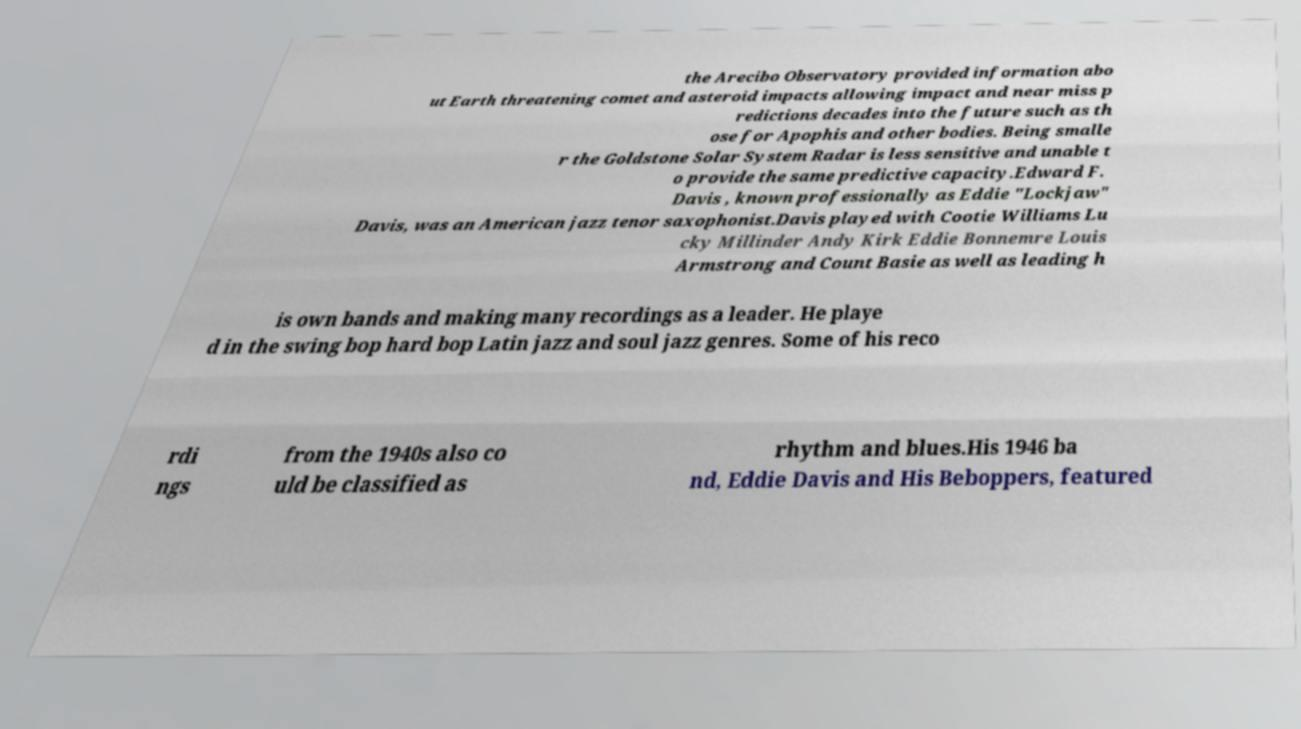Can you accurately transcribe the text from the provided image for me? the Arecibo Observatory provided information abo ut Earth threatening comet and asteroid impacts allowing impact and near miss p redictions decades into the future such as th ose for Apophis and other bodies. Being smalle r the Goldstone Solar System Radar is less sensitive and unable t o provide the same predictive capacity.Edward F. Davis , known professionally as Eddie "Lockjaw" Davis, was an American jazz tenor saxophonist.Davis played with Cootie Williams Lu cky Millinder Andy Kirk Eddie Bonnemre Louis Armstrong and Count Basie as well as leading h is own bands and making many recordings as a leader. He playe d in the swing bop hard bop Latin jazz and soul jazz genres. Some of his reco rdi ngs from the 1940s also co uld be classified as rhythm and blues.His 1946 ba nd, Eddie Davis and His Beboppers, featured 